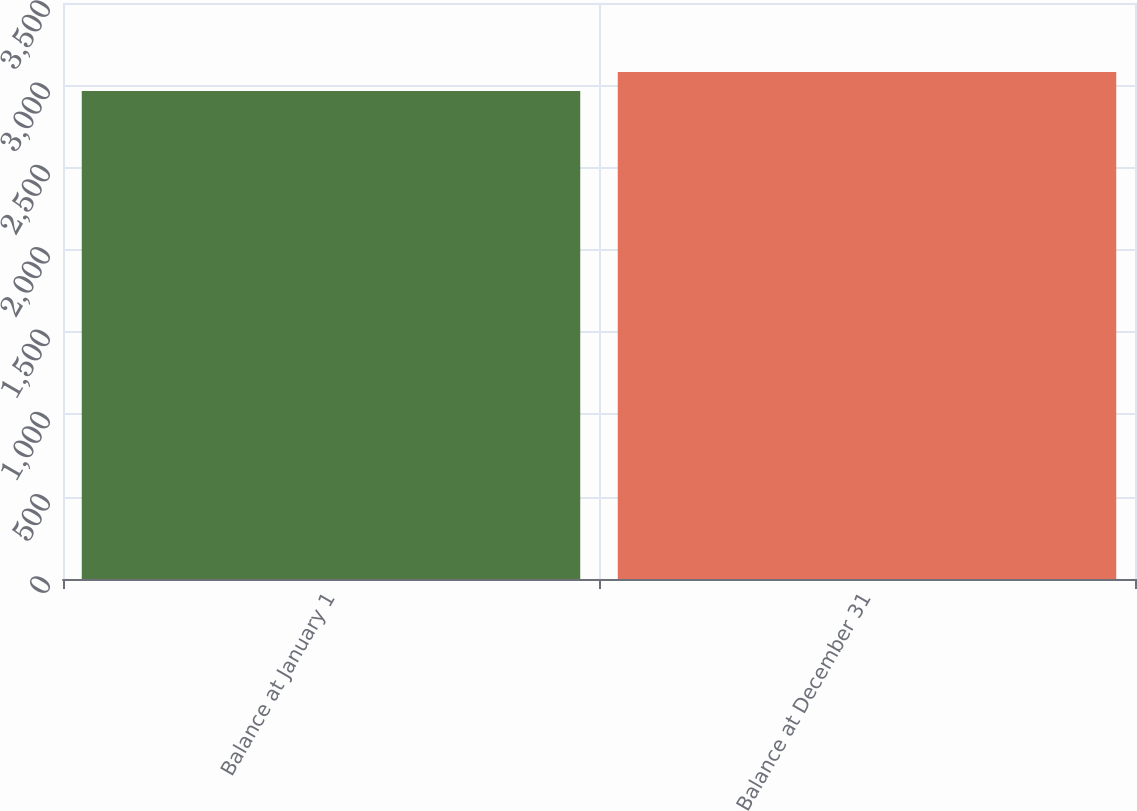Convert chart to OTSL. <chart><loc_0><loc_0><loc_500><loc_500><bar_chart><fcel>Balance at January 1<fcel>Balance at December 31<nl><fcel>2965<fcel>3080<nl></chart> 